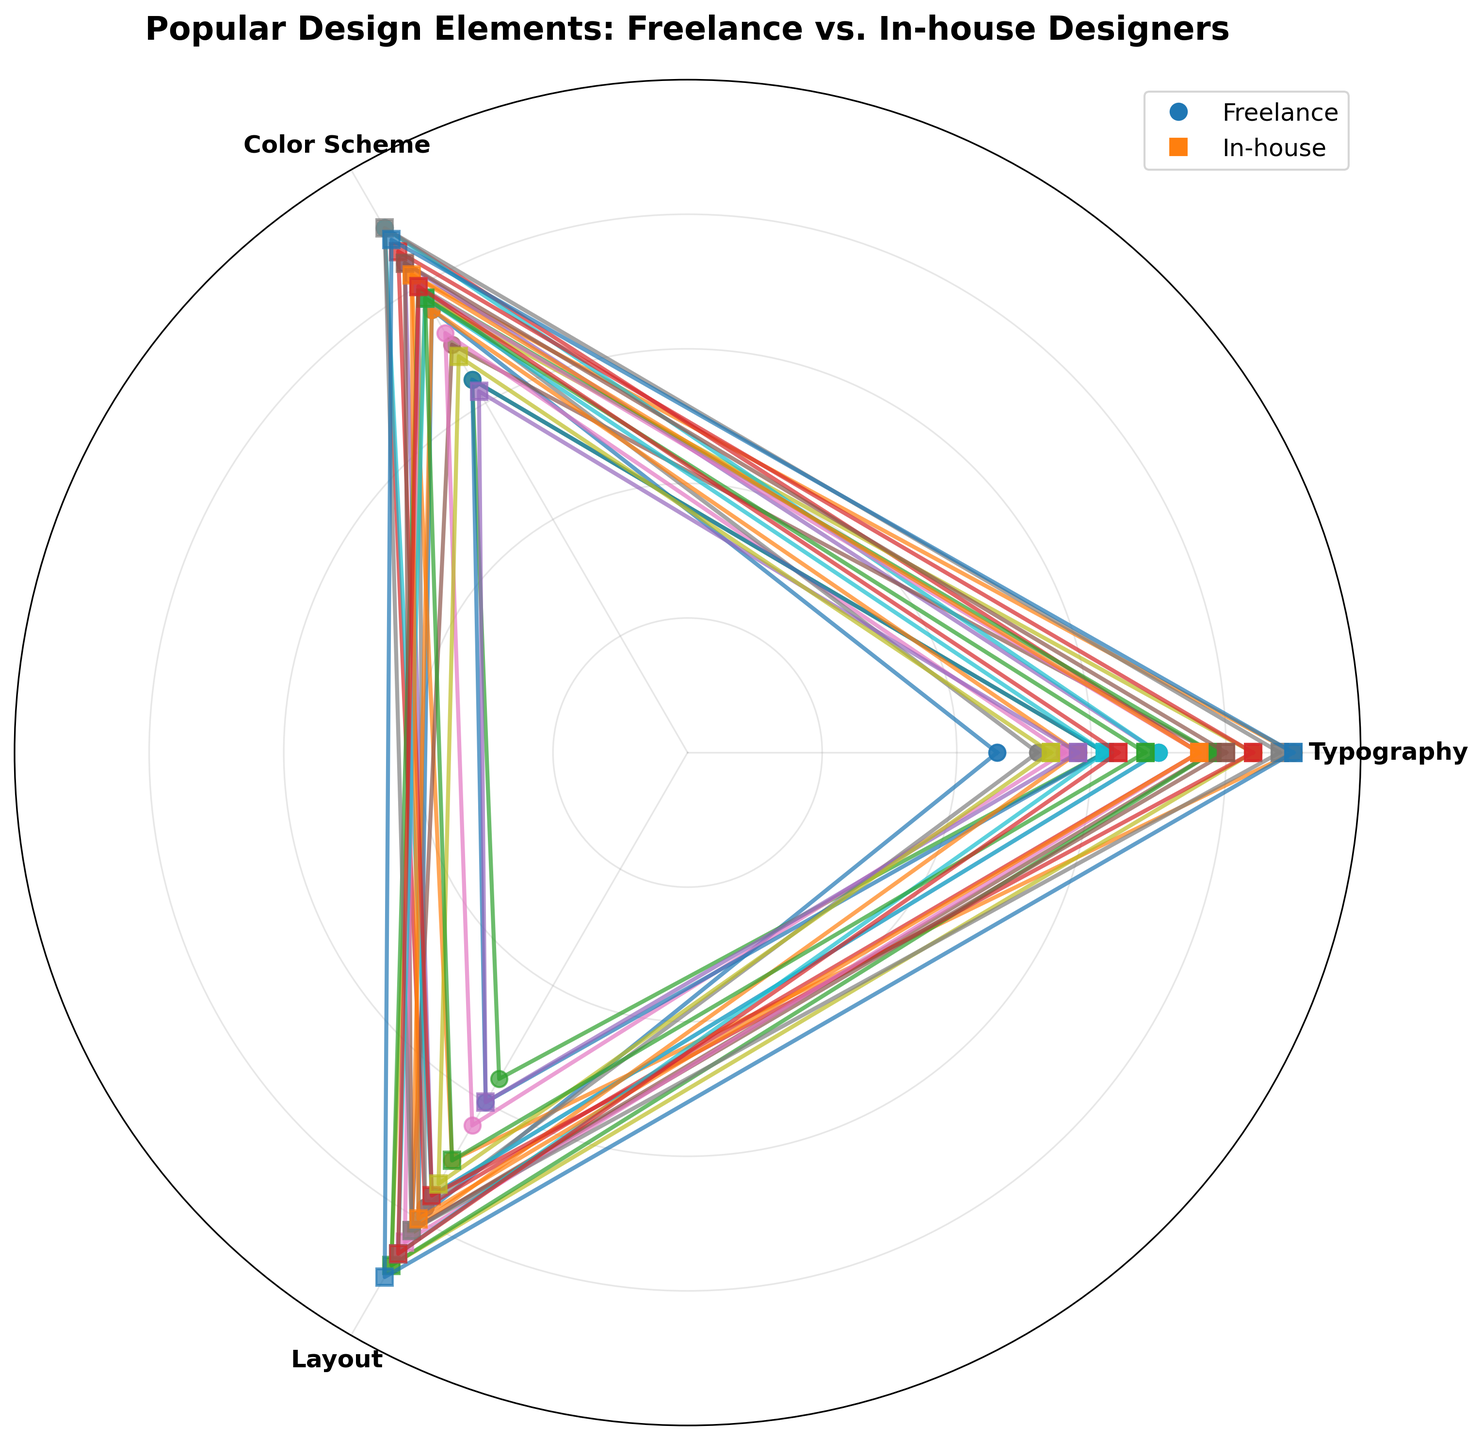What's the title of the chart? The title of the chart is typically at the top and summarizes what the chart is about.
Answer: Popular Design Elements: Freelance vs. In-house Designers What are the categories represented on the polar scatter chart? The categories are usually shown as labels around the polar chart and indicate what aspects are being measured.
Answer: Typography, Color Scheme, Layout How many different legend elements are shown in the plot? The legend helps identify different groups within the data. By counting the legend elements, we can determine the number of groups.
Answer: 2 Which design element has the highest value among freelancers for the Layout category? Identify the category "Layout" and then find the highest value among the freelance data points.
Answer: Grid Layout Compare the usage of Serif Fonts between freelance and in-house designers in the Typography category. Which one is higher? Locate the Serif Fonts values in the Typography category for both freelancers and in-house, and compare them.
Answer: In-house What is the average score for 'Modern Fonts' across all categories for in-house designers? Add the scores for Modern Fonts in Typography, Color Scheme, and Layout, then divide by the number of categories.
Answer: 4.1 Which design type uses Pastel Colors more frequently in the Color Scheme category? Compare the values of Pastel Colors in the Color Scheme category for both freelance and in-house designers.
Answer: Freelance In which category do in-house designers rate 'Grid Layout' the highest? Look at the 'Grid Layout' values for each category (Typography, Color Scheme, Layout) and identify the category with the highest value.
Answer: Layout For which category do freelance designers have the smallest range of values? Calculate the range (maximum value - minimum value) for each category among freelance designers and identify the smallest range.
Answer: Typography Do in-house designers prefer Asymmetrical Layouts more than single-page layouts in the Layout category? Compare the values for Asymmetrical Layout and Single Page Layout within the in-house design type in the Layout category.
Answer: Yes 